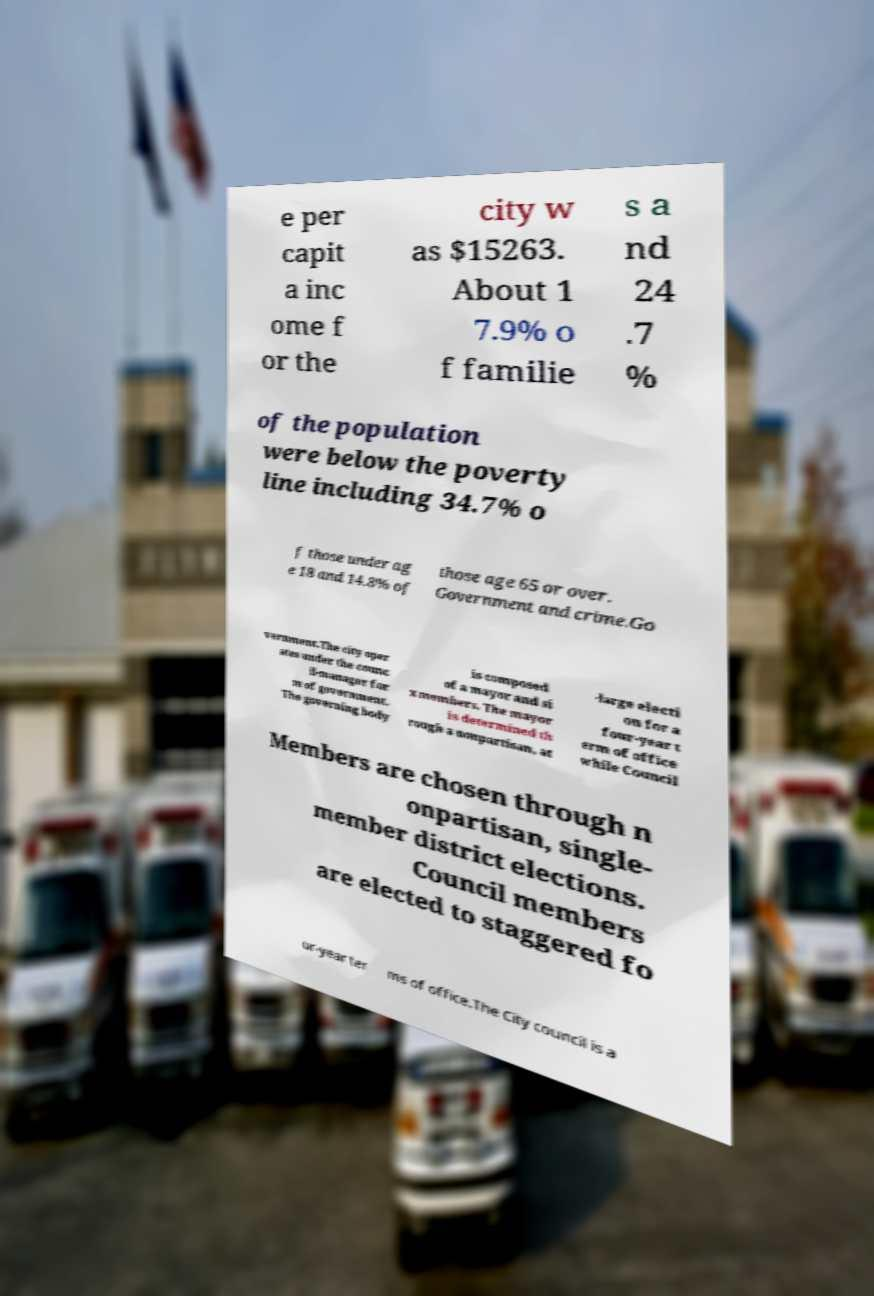Can you accurately transcribe the text from the provided image for me? e per capit a inc ome f or the city w as $15263. About 1 7.9% o f familie s a nd 24 .7 % of the population were below the poverty line including 34.7% o f those under ag e 18 and 14.8% of those age 65 or over. Government and crime.Go vernment.The city oper ates under the counc il-manager for m of government. The governing body is composed of a mayor and si x members. The mayor is determined th rough a nonpartisan, at -large electi on for a four-year t erm of office while Council Members are chosen through n onpartisan, single- member district elections. Council members are elected to staggered fo ur-year ter ms of office.The City council is a 